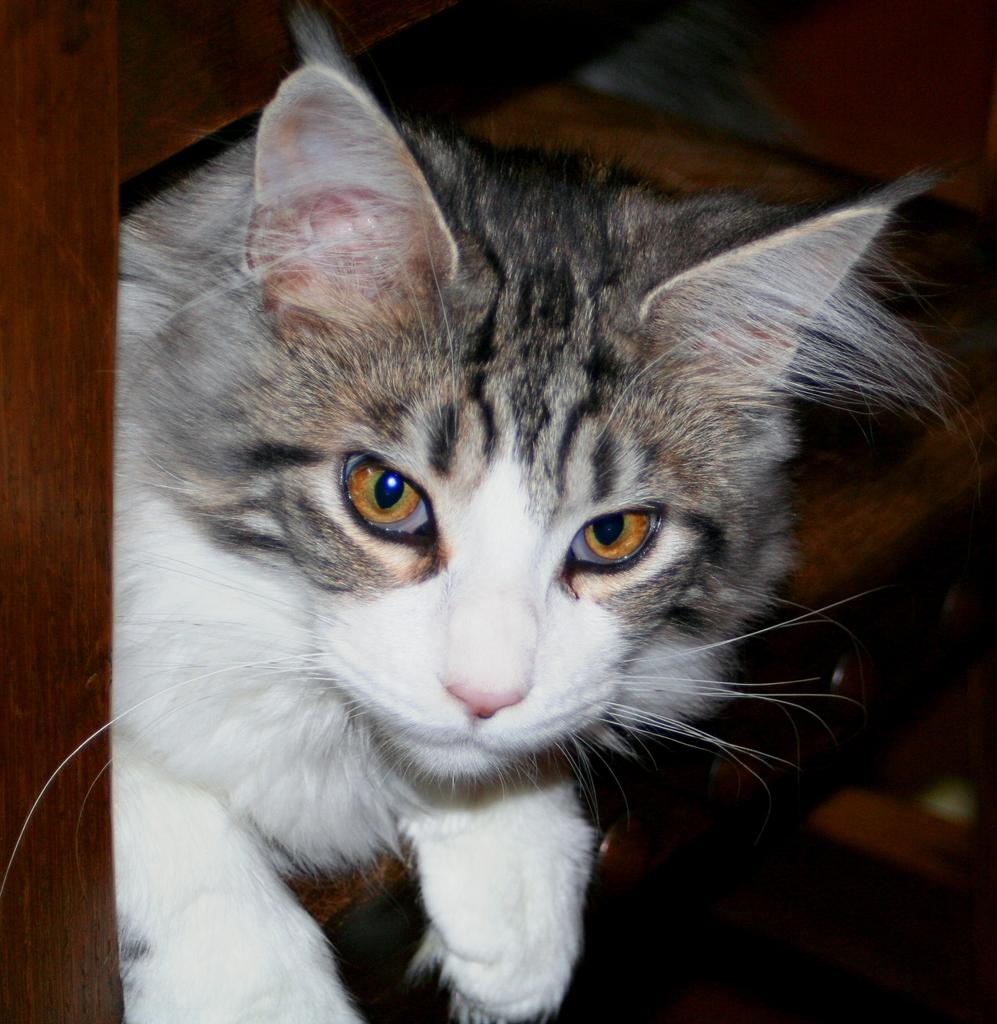What type of animal is in the image? There is a cat in the image. What material is the object made of in the image? The object in the image is made of wood. Is the cat stuck in quicksand in the image? No, there is no quicksand present in the image, and the cat is not stuck. What advice would the cat's grandmother give in the image? There is no grandmother present in the image, so it is not possible to determine what advice she might give. 